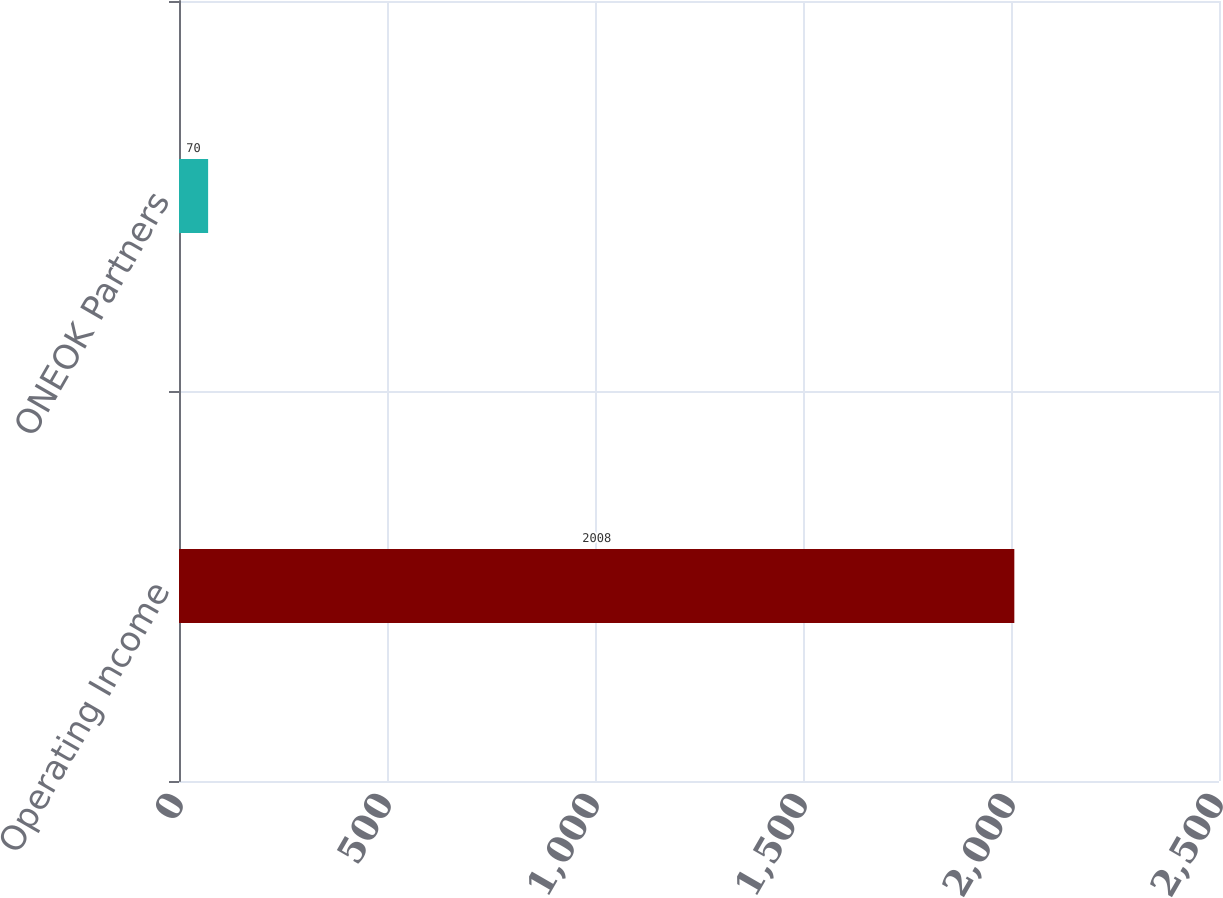Convert chart. <chart><loc_0><loc_0><loc_500><loc_500><bar_chart><fcel>Operating Income<fcel>ONEOK Partners<nl><fcel>2008<fcel>70<nl></chart> 